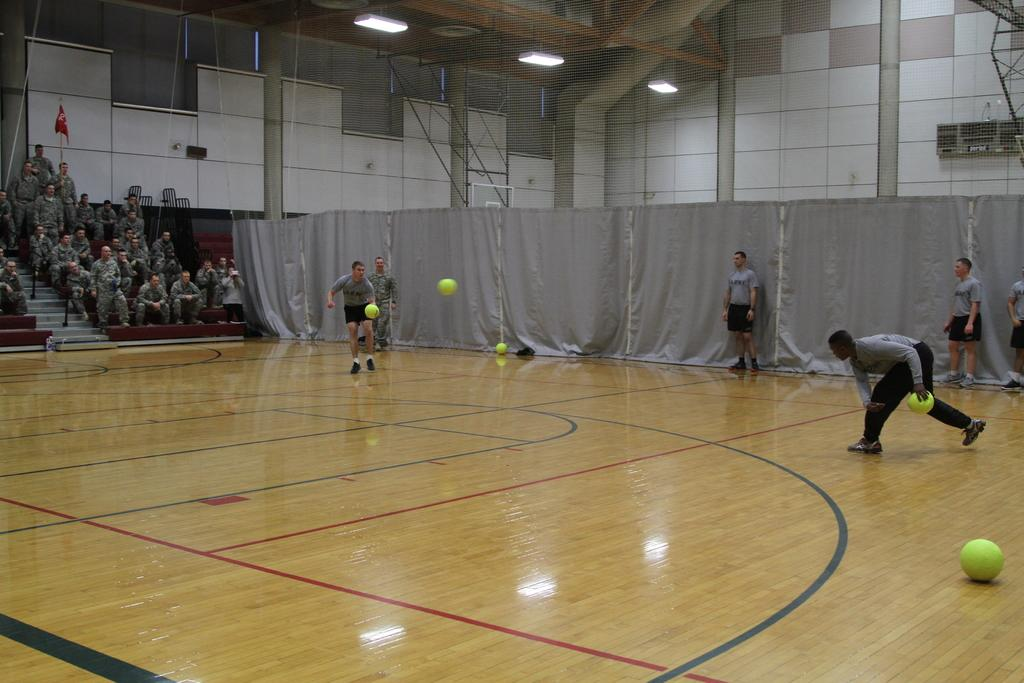How many people are in the image? There are people in the image, but the exact number is not specified. What can be seen hanging in the image? There are curtains and a flag in the image. What type of material is present in the image? There is mesh in the image. What is used for illumination in the image? There are lights in the image. What architectural feature is present in the image? There are walls and steps in the image. What objects are being held by some people in the image? Two people are holding balls in the image. What are some people doing in the image? Some people are sitting in the image. What type of thread is being used to sew the gate in the image? There is no gate present in the image, so there is no thread being used to sew it. 